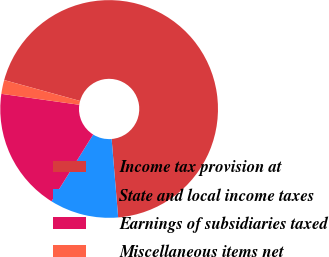Convert chart. <chart><loc_0><loc_0><loc_500><loc_500><pie_chart><fcel>Income tax provision at<fcel>State and local income taxes<fcel>Earnings of subsidiaries taxed<fcel>Miscellaneous items net<nl><fcel>69.4%<fcel>10.2%<fcel>18.34%<fcel>2.06%<nl></chart> 